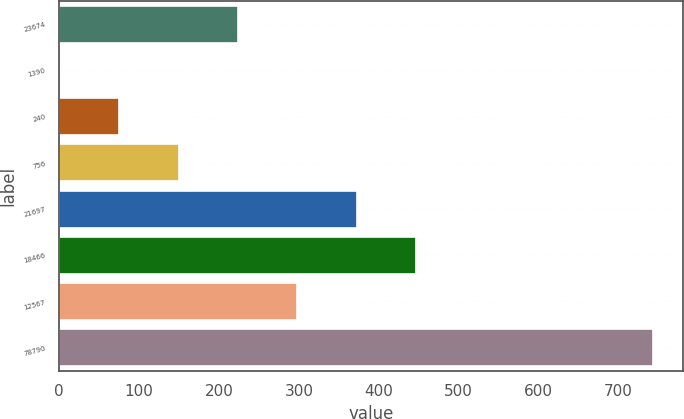Convert chart to OTSL. <chart><loc_0><loc_0><loc_500><loc_500><bar_chart><fcel>23674<fcel>1390<fcel>240<fcel>756<fcel>21697<fcel>18466<fcel>12567<fcel>78790<nl><fcel>223.66<fcel>1<fcel>75.22<fcel>149.44<fcel>372.1<fcel>446.32<fcel>297.88<fcel>743.2<nl></chart> 